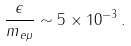<formula> <loc_0><loc_0><loc_500><loc_500>\frac { \epsilon } { m _ { e \mu } } \sim 5 \times 1 0 ^ { - 3 } \, .</formula> 